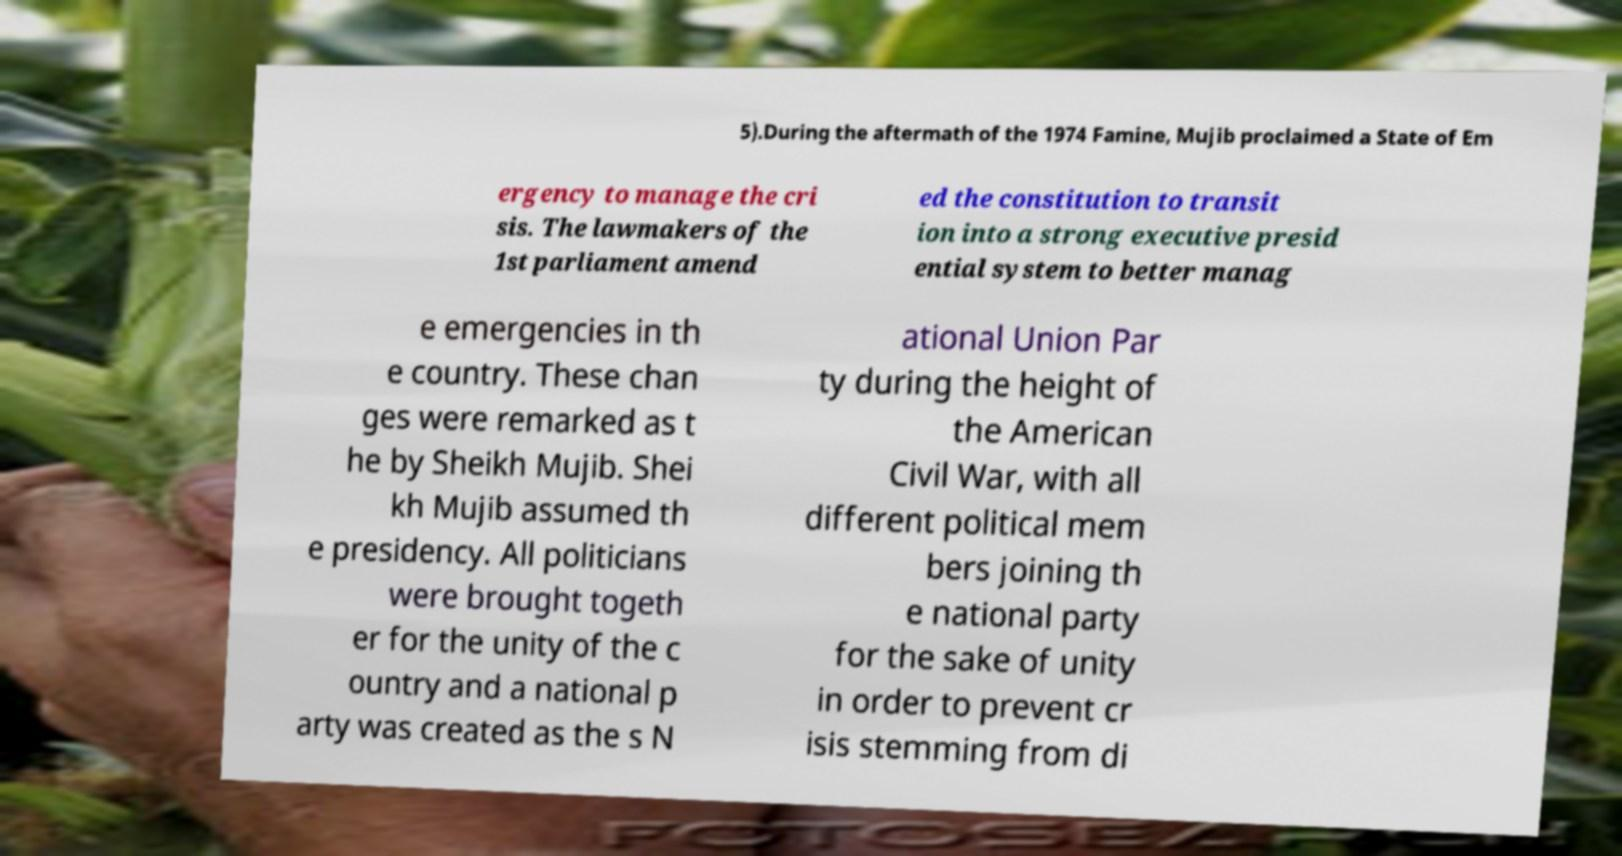I need the written content from this picture converted into text. Can you do that? 5).During the aftermath of the 1974 Famine, Mujib proclaimed a State of Em ergency to manage the cri sis. The lawmakers of the 1st parliament amend ed the constitution to transit ion into a strong executive presid ential system to better manag e emergencies in th e country. These chan ges were remarked as t he by Sheikh Mujib. Shei kh Mujib assumed th e presidency. All politicians were brought togeth er for the unity of the c ountry and a national p arty was created as the s N ational Union Par ty during the height of the American Civil War, with all different political mem bers joining th e national party for the sake of unity in order to prevent cr isis stemming from di 